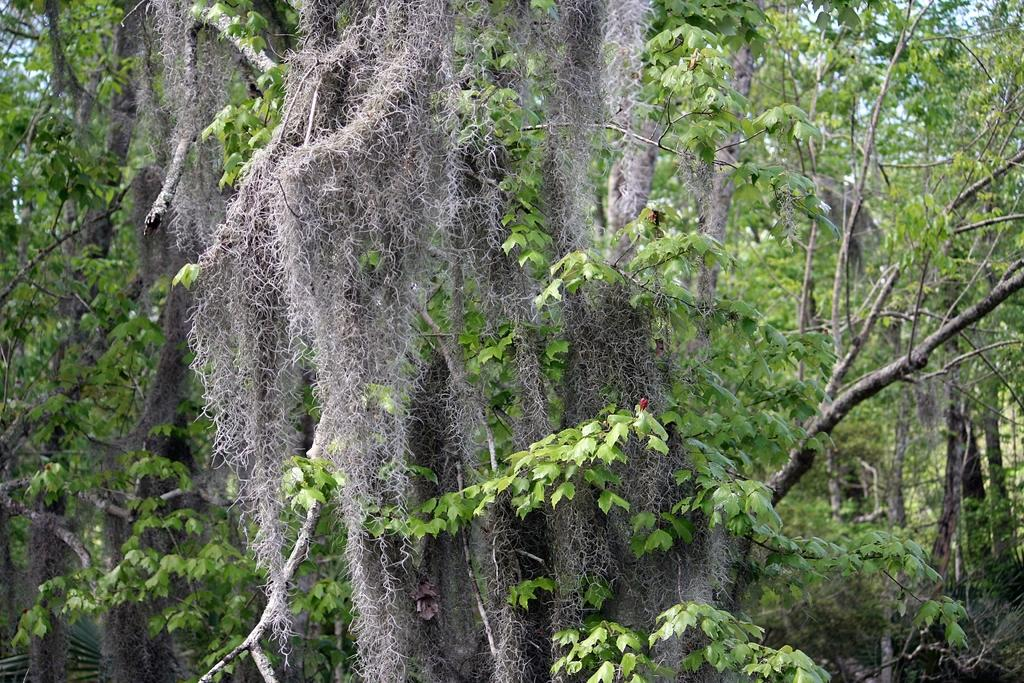What type of vegetation can be seen in the image? There are trees in the image. What is visible at the top of the image? The sky is visible at the top of the image. How does the clam contribute to the pollution in the image? There is no clam present in the image, so it cannot contribute to any pollution. 